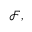<formula> <loc_0><loc_0><loc_500><loc_500>{ \mathcal { F } } ,</formula> 